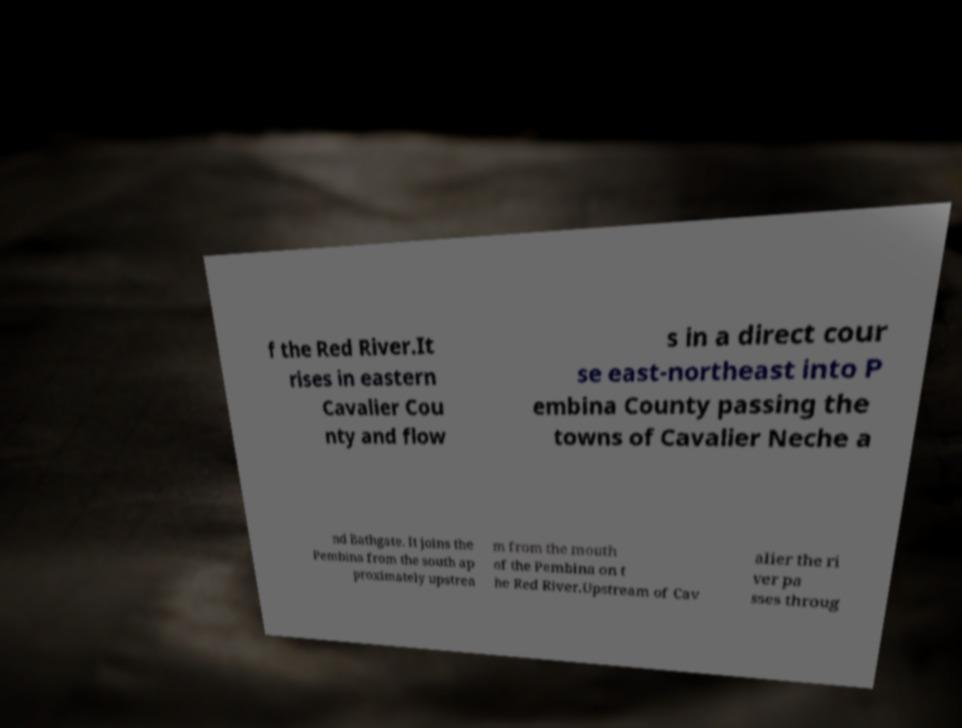Please identify and transcribe the text found in this image. f the Red River.It rises in eastern Cavalier Cou nty and flow s in a direct cour se east-northeast into P embina County passing the towns of Cavalier Neche a nd Bathgate. It joins the Pembina from the south ap proximately upstrea m from the mouth of the Pembina on t he Red River.Upstream of Cav alier the ri ver pa sses throug 